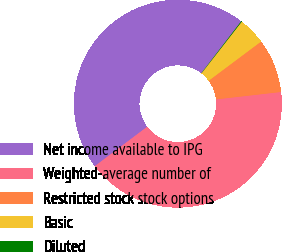<chart> <loc_0><loc_0><loc_500><loc_500><pie_chart><fcel>Net income available to IPG<fcel>Weighted-average number of<fcel>Restricted stock stock options<fcel>Basic<fcel>Diluted<nl><fcel>45.7%<fcel>41.54%<fcel>8.41%<fcel>4.25%<fcel>0.1%<nl></chart> 